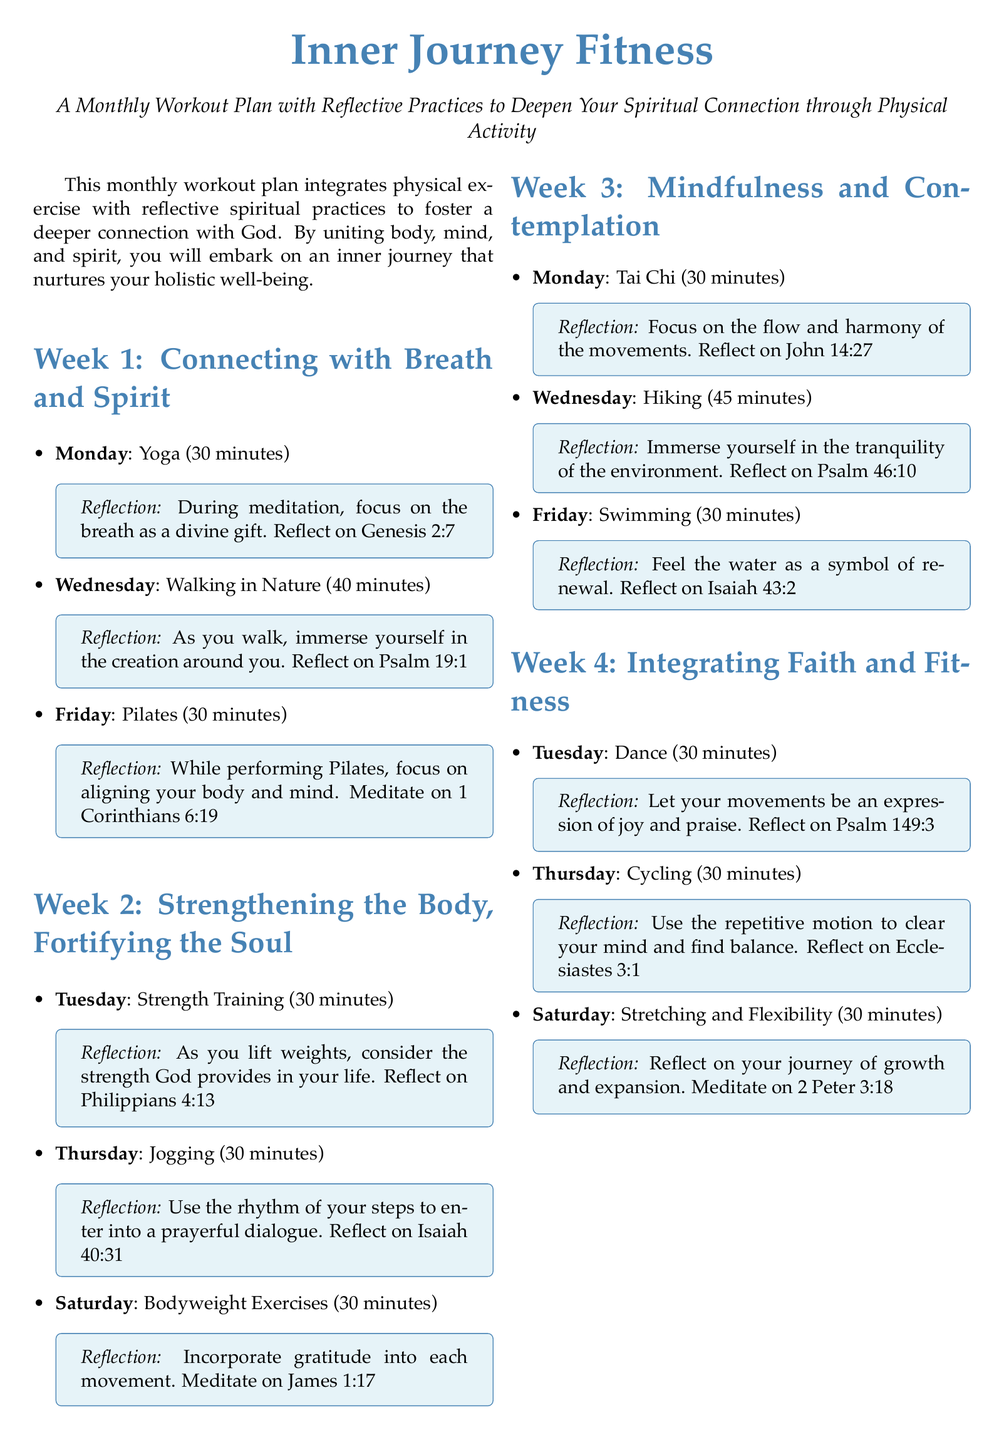What is the title of the document? The title indicates the main focus or theme of the document, which is "Inner Journey Fitness."
Answer: Inner Journey Fitness How many weeks of workouts are included in the plan? The document outlines a workout plan structured by weeks, totaling four weeks.
Answer: 4 What type of exercise is suggested for Monday of Week 1? Each day of the week is assigned a specific type of exercise, and Monday of Week 1 recommends "Yoga."
Answer: Yoga Which biblical verse is associated with stretching and flexibility? The document provides corresponding scripture for each workout, and stretching and flexibility is linked to "2 Peter 3:18."
Answer: 2 Peter 3:18 What activity is performed on Saturdays during Week 2? Each Saturday in the document shows planned activities, and in Week 2, the activity is "Bodyweight Exercises."
Answer: Bodyweight Exercises What is the duration of the yoga session in Week 1? The specifics of each session's length are provided, and the yoga session in Week 1 lasts for "30 minutes."
Answer: 30 minutes What reflective practice is included in the jogging session? Each workout also integrates a reflective practice, and for jogging, it emphasizes "entering into a prayerful dialogue."
Answer: Enter into a prayerful dialogue How does the plan suggest to connect physical activity with spirituality? The document illustrates that the plan unites physical exercises with reflective spiritual practices to enhance well-being.
Answer: Through reflective spiritual practices What is the main goal of the "Inner Journey Fitness" plan? The overall purpose of the document is to facilitate a deeper connection with God through workouts, thus promoting holistic well-being.
Answer: Deepen your spiritual connection 